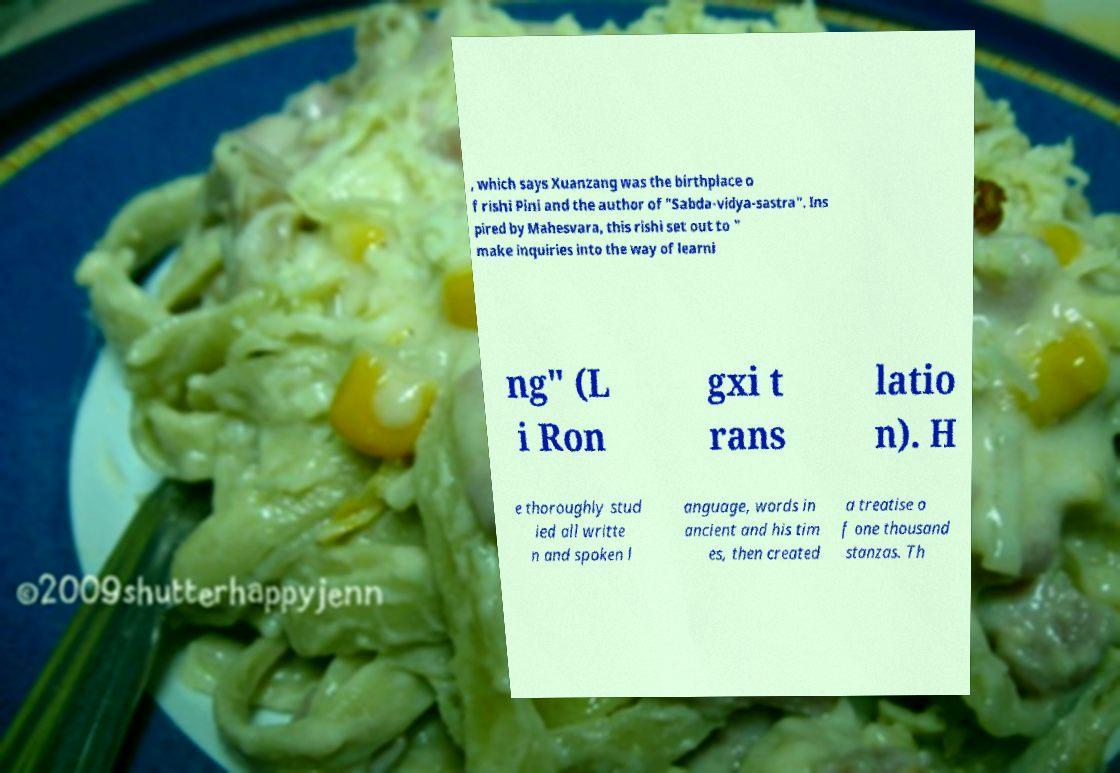Could you assist in decoding the text presented in this image and type it out clearly? , which says Xuanzang was the birthplace o f rishi Pini and the author of "Sabda-vidya-sastra". Ins pired by Mahesvara, this rishi set out to " make inquiries into the way of learni ng" (L i Ron gxi t rans latio n). H e thoroughly stud ied all writte n and spoken l anguage, words in ancient and his tim es, then created a treatise o f one thousand stanzas. Th 